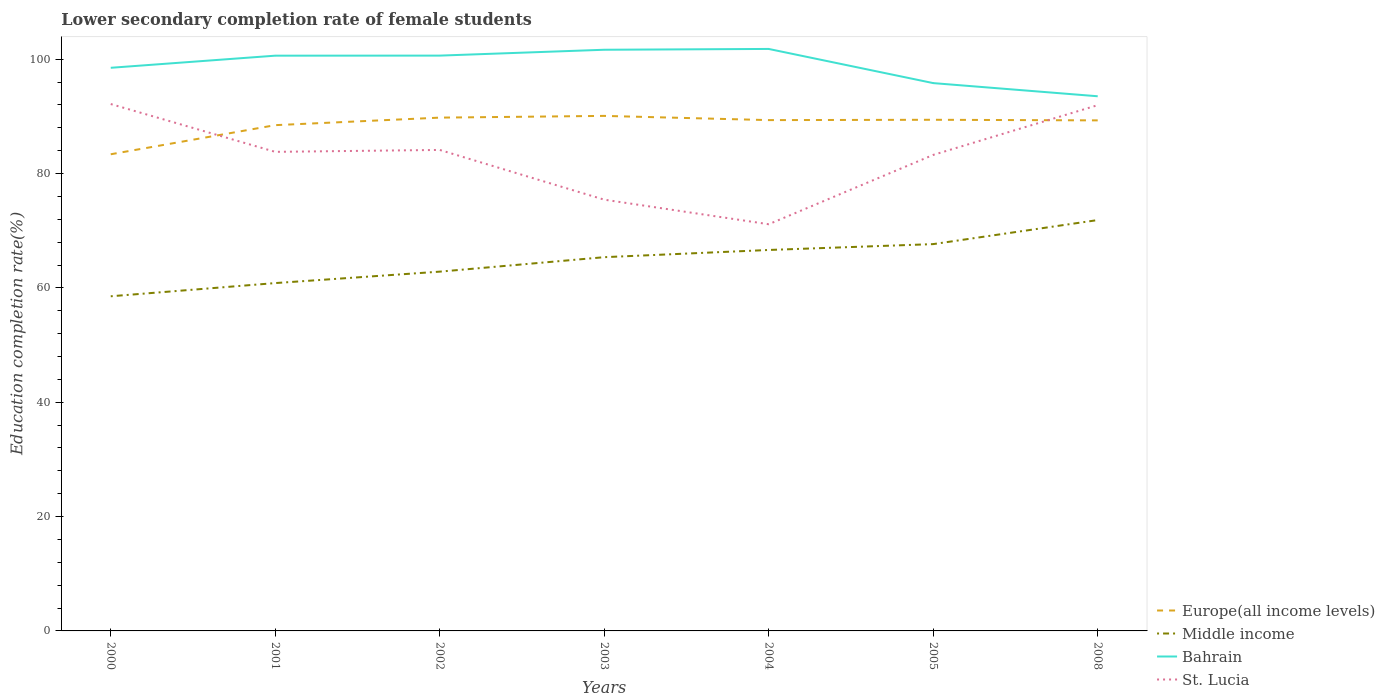How many different coloured lines are there?
Your answer should be very brief. 4. Is the number of lines equal to the number of legend labels?
Ensure brevity in your answer.  Yes. Across all years, what is the maximum lower secondary completion rate of female students in Bahrain?
Your response must be concise. 93.52. What is the total lower secondary completion rate of female students in St. Lucia in the graph?
Provide a short and direct response. -8.7. What is the difference between the highest and the second highest lower secondary completion rate of female students in Middle income?
Keep it short and to the point. 13.33. How many years are there in the graph?
Your answer should be compact. 7. Are the values on the major ticks of Y-axis written in scientific E-notation?
Offer a terse response. No. Does the graph contain any zero values?
Ensure brevity in your answer.  No. Where does the legend appear in the graph?
Provide a succinct answer. Bottom right. How many legend labels are there?
Keep it short and to the point. 4. How are the legend labels stacked?
Provide a succinct answer. Vertical. What is the title of the graph?
Offer a terse response. Lower secondary completion rate of female students. Does "Iran" appear as one of the legend labels in the graph?
Give a very brief answer. No. What is the label or title of the X-axis?
Keep it short and to the point. Years. What is the label or title of the Y-axis?
Make the answer very short. Education completion rate(%). What is the Education completion rate(%) in Europe(all income levels) in 2000?
Provide a short and direct response. 83.38. What is the Education completion rate(%) in Middle income in 2000?
Your answer should be compact. 58.54. What is the Education completion rate(%) in Bahrain in 2000?
Offer a very short reply. 98.5. What is the Education completion rate(%) in St. Lucia in 2000?
Your answer should be very brief. 92.16. What is the Education completion rate(%) in Europe(all income levels) in 2001?
Make the answer very short. 88.47. What is the Education completion rate(%) in Middle income in 2001?
Provide a short and direct response. 60.85. What is the Education completion rate(%) of Bahrain in 2001?
Your answer should be very brief. 100.62. What is the Education completion rate(%) of St. Lucia in 2001?
Your answer should be very brief. 83.8. What is the Education completion rate(%) of Europe(all income levels) in 2002?
Your response must be concise. 89.79. What is the Education completion rate(%) of Middle income in 2002?
Offer a terse response. 62.85. What is the Education completion rate(%) in Bahrain in 2002?
Your answer should be very brief. 100.64. What is the Education completion rate(%) in St. Lucia in 2002?
Your response must be concise. 84.14. What is the Education completion rate(%) in Europe(all income levels) in 2003?
Provide a short and direct response. 90.09. What is the Education completion rate(%) in Middle income in 2003?
Provide a succinct answer. 65.38. What is the Education completion rate(%) of Bahrain in 2003?
Provide a succinct answer. 101.66. What is the Education completion rate(%) of St. Lucia in 2003?
Your response must be concise. 75.44. What is the Education completion rate(%) of Europe(all income levels) in 2004?
Offer a very short reply. 89.35. What is the Education completion rate(%) in Middle income in 2004?
Provide a succinct answer. 66.64. What is the Education completion rate(%) of Bahrain in 2004?
Offer a terse response. 101.8. What is the Education completion rate(%) in St. Lucia in 2004?
Your answer should be very brief. 71.14. What is the Education completion rate(%) of Europe(all income levels) in 2005?
Make the answer very short. 89.41. What is the Education completion rate(%) in Middle income in 2005?
Your answer should be very brief. 67.66. What is the Education completion rate(%) in Bahrain in 2005?
Give a very brief answer. 95.83. What is the Education completion rate(%) of St. Lucia in 2005?
Ensure brevity in your answer.  83.27. What is the Education completion rate(%) in Europe(all income levels) in 2008?
Keep it short and to the point. 89.31. What is the Education completion rate(%) of Middle income in 2008?
Make the answer very short. 71.87. What is the Education completion rate(%) of Bahrain in 2008?
Your response must be concise. 93.52. What is the Education completion rate(%) of St. Lucia in 2008?
Provide a succinct answer. 91.97. Across all years, what is the maximum Education completion rate(%) in Europe(all income levels)?
Offer a very short reply. 90.09. Across all years, what is the maximum Education completion rate(%) in Middle income?
Offer a terse response. 71.87. Across all years, what is the maximum Education completion rate(%) of Bahrain?
Provide a short and direct response. 101.8. Across all years, what is the maximum Education completion rate(%) of St. Lucia?
Keep it short and to the point. 92.16. Across all years, what is the minimum Education completion rate(%) in Europe(all income levels)?
Ensure brevity in your answer.  83.38. Across all years, what is the minimum Education completion rate(%) of Middle income?
Offer a terse response. 58.54. Across all years, what is the minimum Education completion rate(%) of Bahrain?
Your answer should be very brief. 93.52. Across all years, what is the minimum Education completion rate(%) in St. Lucia?
Ensure brevity in your answer.  71.14. What is the total Education completion rate(%) of Europe(all income levels) in the graph?
Keep it short and to the point. 619.8. What is the total Education completion rate(%) of Middle income in the graph?
Your answer should be compact. 453.77. What is the total Education completion rate(%) in Bahrain in the graph?
Keep it short and to the point. 692.58. What is the total Education completion rate(%) of St. Lucia in the graph?
Give a very brief answer. 581.91. What is the difference between the Education completion rate(%) of Europe(all income levels) in 2000 and that in 2001?
Offer a terse response. -5.09. What is the difference between the Education completion rate(%) of Middle income in 2000 and that in 2001?
Your answer should be very brief. -2.31. What is the difference between the Education completion rate(%) of Bahrain in 2000 and that in 2001?
Offer a terse response. -2.12. What is the difference between the Education completion rate(%) in St. Lucia in 2000 and that in 2001?
Your answer should be very brief. 8.36. What is the difference between the Education completion rate(%) of Europe(all income levels) in 2000 and that in 2002?
Your answer should be compact. -6.41. What is the difference between the Education completion rate(%) in Middle income in 2000 and that in 2002?
Your answer should be very brief. -4.31. What is the difference between the Education completion rate(%) of Bahrain in 2000 and that in 2002?
Your answer should be compact. -2.13. What is the difference between the Education completion rate(%) of St. Lucia in 2000 and that in 2002?
Offer a very short reply. 8.03. What is the difference between the Education completion rate(%) of Europe(all income levels) in 2000 and that in 2003?
Your answer should be very brief. -6.71. What is the difference between the Education completion rate(%) in Middle income in 2000 and that in 2003?
Your answer should be very brief. -6.84. What is the difference between the Education completion rate(%) in Bahrain in 2000 and that in 2003?
Provide a short and direct response. -3.15. What is the difference between the Education completion rate(%) in St. Lucia in 2000 and that in 2003?
Ensure brevity in your answer.  16.73. What is the difference between the Education completion rate(%) of Europe(all income levels) in 2000 and that in 2004?
Provide a short and direct response. -5.98. What is the difference between the Education completion rate(%) in Middle income in 2000 and that in 2004?
Ensure brevity in your answer.  -8.1. What is the difference between the Education completion rate(%) in Bahrain in 2000 and that in 2004?
Provide a succinct answer. -3.3. What is the difference between the Education completion rate(%) of St. Lucia in 2000 and that in 2004?
Your answer should be very brief. 21.03. What is the difference between the Education completion rate(%) of Europe(all income levels) in 2000 and that in 2005?
Offer a terse response. -6.03. What is the difference between the Education completion rate(%) of Middle income in 2000 and that in 2005?
Offer a terse response. -9.12. What is the difference between the Education completion rate(%) of Bahrain in 2000 and that in 2005?
Provide a short and direct response. 2.68. What is the difference between the Education completion rate(%) of St. Lucia in 2000 and that in 2005?
Keep it short and to the point. 8.9. What is the difference between the Education completion rate(%) of Europe(all income levels) in 2000 and that in 2008?
Your answer should be compact. -5.93. What is the difference between the Education completion rate(%) of Middle income in 2000 and that in 2008?
Your answer should be very brief. -13.33. What is the difference between the Education completion rate(%) in Bahrain in 2000 and that in 2008?
Offer a very short reply. 4.98. What is the difference between the Education completion rate(%) of St. Lucia in 2000 and that in 2008?
Provide a short and direct response. 0.2. What is the difference between the Education completion rate(%) in Europe(all income levels) in 2001 and that in 2002?
Keep it short and to the point. -1.32. What is the difference between the Education completion rate(%) in Middle income in 2001 and that in 2002?
Offer a terse response. -2. What is the difference between the Education completion rate(%) of Bahrain in 2001 and that in 2002?
Your response must be concise. -0.01. What is the difference between the Education completion rate(%) in St. Lucia in 2001 and that in 2002?
Your answer should be very brief. -0.34. What is the difference between the Education completion rate(%) of Europe(all income levels) in 2001 and that in 2003?
Your answer should be compact. -1.62. What is the difference between the Education completion rate(%) in Middle income in 2001 and that in 2003?
Offer a terse response. -4.53. What is the difference between the Education completion rate(%) of Bahrain in 2001 and that in 2003?
Provide a short and direct response. -1.03. What is the difference between the Education completion rate(%) of St. Lucia in 2001 and that in 2003?
Provide a succinct answer. 8.36. What is the difference between the Education completion rate(%) in Europe(all income levels) in 2001 and that in 2004?
Give a very brief answer. -0.88. What is the difference between the Education completion rate(%) in Middle income in 2001 and that in 2004?
Your response must be concise. -5.79. What is the difference between the Education completion rate(%) of Bahrain in 2001 and that in 2004?
Keep it short and to the point. -1.18. What is the difference between the Education completion rate(%) in St. Lucia in 2001 and that in 2004?
Your answer should be very brief. 12.66. What is the difference between the Education completion rate(%) of Europe(all income levels) in 2001 and that in 2005?
Provide a short and direct response. -0.94. What is the difference between the Education completion rate(%) in Middle income in 2001 and that in 2005?
Provide a succinct answer. -6.82. What is the difference between the Education completion rate(%) of Bahrain in 2001 and that in 2005?
Your answer should be very brief. 4.8. What is the difference between the Education completion rate(%) in St. Lucia in 2001 and that in 2005?
Keep it short and to the point. 0.53. What is the difference between the Education completion rate(%) of Europe(all income levels) in 2001 and that in 2008?
Give a very brief answer. -0.83. What is the difference between the Education completion rate(%) of Middle income in 2001 and that in 2008?
Your answer should be compact. -11.02. What is the difference between the Education completion rate(%) of Bahrain in 2001 and that in 2008?
Provide a succinct answer. 7.1. What is the difference between the Education completion rate(%) in St. Lucia in 2001 and that in 2008?
Offer a terse response. -8.17. What is the difference between the Education completion rate(%) of Europe(all income levels) in 2002 and that in 2003?
Give a very brief answer. -0.3. What is the difference between the Education completion rate(%) in Middle income in 2002 and that in 2003?
Provide a short and direct response. -2.53. What is the difference between the Education completion rate(%) in Bahrain in 2002 and that in 2003?
Provide a succinct answer. -1.02. What is the difference between the Education completion rate(%) of St. Lucia in 2002 and that in 2003?
Provide a succinct answer. 8.7. What is the difference between the Education completion rate(%) of Europe(all income levels) in 2002 and that in 2004?
Provide a short and direct response. 0.43. What is the difference between the Education completion rate(%) in Middle income in 2002 and that in 2004?
Ensure brevity in your answer.  -3.79. What is the difference between the Education completion rate(%) of Bahrain in 2002 and that in 2004?
Your answer should be very brief. -1.17. What is the difference between the Education completion rate(%) of St. Lucia in 2002 and that in 2004?
Make the answer very short. 13. What is the difference between the Education completion rate(%) of Europe(all income levels) in 2002 and that in 2005?
Provide a short and direct response. 0.38. What is the difference between the Education completion rate(%) in Middle income in 2002 and that in 2005?
Make the answer very short. -4.82. What is the difference between the Education completion rate(%) of Bahrain in 2002 and that in 2005?
Offer a very short reply. 4.81. What is the difference between the Education completion rate(%) in St. Lucia in 2002 and that in 2005?
Keep it short and to the point. 0.87. What is the difference between the Education completion rate(%) of Europe(all income levels) in 2002 and that in 2008?
Offer a terse response. 0.48. What is the difference between the Education completion rate(%) in Middle income in 2002 and that in 2008?
Provide a succinct answer. -9.02. What is the difference between the Education completion rate(%) in Bahrain in 2002 and that in 2008?
Offer a very short reply. 7.11. What is the difference between the Education completion rate(%) of St. Lucia in 2002 and that in 2008?
Ensure brevity in your answer.  -7.83. What is the difference between the Education completion rate(%) of Europe(all income levels) in 2003 and that in 2004?
Give a very brief answer. 0.74. What is the difference between the Education completion rate(%) in Middle income in 2003 and that in 2004?
Provide a short and direct response. -1.26. What is the difference between the Education completion rate(%) of Bahrain in 2003 and that in 2004?
Give a very brief answer. -0.14. What is the difference between the Education completion rate(%) of St. Lucia in 2003 and that in 2004?
Provide a succinct answer. 4.3. What is the difference between the Education completion rate(%) of Europe(all income levels) in 2003 and that in 2005?
Your response must be concise. 0.68. What is the difference between the Education completion rate(%) in Middle income in 2003 and that in 2005?
Your answer should be very brief. -2.29. What is the difference between the Education completion rate(%) of Bahrain in 2003 and that in 2005?
Your response must be concise. 5.83. What is the difference between the Education completion rate(%) of St. Lucia in 2003 and that in 2005?
Offer a terse response. -7.83. What is the difference between the Education completion rate(%) of Europe(all income levels) in 2003 and that in 2008?
Keep it short and to the point. 0.78. What is the difference between the Education completion rate(%) of Middle income in 2003 and that in 2008?
Provide a succinct answer. -6.49. What is the difference between the Education completion rate(%) in Bahrain in 2003 and that in 2008?
Offer a very short reply. 8.14. What is the difference between the Education completion rate(%) of St. Lucia in 2003 and that in 2008?
Provide a short and direct response. -16.53. What is the difference between the Education completion rate(%) in Europe(all income levels) in 2004 and that in 2005?
Make the answer very short. -0.06. What is the difference between the Education completion rate(%) of Middle income in 2004 and that in 2005?
Give a very brief answer. -1.03. What is the difference between the Education completion rate(%) of Bahrain in 2004 and that in 2005?
Keep it short and to the point. 5.98. What is the difference between the Education completion rate(%) of St. Lucia in 2004 and that in 2005?
Offer a terse response. -12.13. What is the difference between the Education completion rate(%) of Europe(all income levels) in 2004 and that in 2008?
Ensure brevity in your answer.  0.05. What is the difference between the Education completion rate(%) of Middle income in 2004 and that in 2008?
Offer a very short reply. -5.23. What is the difference between the Education completion rate(%) of Bahrain in 2004 and that in 2008?
Provide a short and direct response. 8.28. What is the difference between the Education completion rate(%) of St. Lucia in 2004 and that in 2008?
Make the answer very short. -20.83. What is the difference between the Education completion rate(%) of Europe(all income levels) in 2005 and that in 2008?
Your answer should be very brief. 0.11. What is the difference between the Education completion rate(%) in Middle income in 2005 and that in 2008?
Provide a succinct answer. -4.21. What is the difference between the Education completion rate(%) of Bahrain in 2005 and that in 2008?
Offer a very short reply. 2.3. What is the difference between the Education completion rate(%) in St. Lucia in 2005 and that in 2008?
Keep it short and to the point. -8.7. What is the difference between the Education completion rate(%) of Europe(all income levels) in 2000 and the Education completion rate(%) of Middle income in 2001?
Offer a terse response. 22.53. What is the difference between the Education completion rate(%) in Europe(all income levels) in 2000 and the Education completion rate(%) in Bahrain in 2001?
Offer a very short reply. -17.25. What is the difference between the Education completion rate(%) in Europe(all income levels) in 2000 and the Education completion rate(%) in St. Lucia in 2001?
Keep it short and to the point. -0.42. What is the difference between the Education completion rate(%) in Middle income in 2000 and the Education completion rate(%) in Bahrain in 2001?
Make the answer very short. -42.09. What is the difference between the Education completion rate(%) of Middle income in 2000 and the Education completion rate(%) of St. Lucia in 2001?
Make the answer very short. -25.26. What is the difference between the Education completion rate(%) of Bahrain in 2000 and the Education completion rate(%) of St. Lucia in 2001?
Ensure brevity in your answer.  14.7. What is the difference between the Education completion rate(%) of Europe(all income levels) in 2000 and the Education completion rate(%) of Middle income in 2002?
Offer a terse response. 20.53. What is the difference between the Education completion rate(%) in Europe(all income levels) in 2000 and the Education completion rate(%) in Bahrain in 2002?
Offer a terse response. -17.26. What is the difference between the Education completion rate(%) in Europe(all income levels) in 2000 and the Education completion rate(%) in St. Lucia in 2002?
Offer a terse response. -0.76. What is the difference between the Education completion rate(%) of Middle income in 2000 and the Education completion rate(%) of Bahrain in 2002?
Keep it short and to the point. -42.1. What is the difference between the Education completion rate(%) of Middle income in 2000 and the Education completion rate(%) of St. Lucia in 2002?
Provide a succinct answer. -25.6. What is the difference between the Education completion rate(%) in Bahrain in 2000 and the Education completion rate(%) in St. Lucia in 2002?
Your answer should be very brief. 14.37. What is the difference between the Education completion rate(%) in Europe(all income levels) in 2000 and the Education completion rate(%) in Middle income in 2003?
Provide a succinct answer. 18. What is the difference between the Education completion rate(%) in Europe(all income levels) in 2000 and the Education completion rate(%) in Bahrain in 2003?
Your answer should be very brief. -18.28. What is the difference between the Education completion rate(%) of Europe(all income levels) in 2000 and the Education completion rate(%) of St. Lucia in 2003?
Provide a short and direct response. 7.94. What is the difference between the Education completion rate(%) of Middle income in 2000 and the Education completion rate(%) of Bahrain in 2003?
Ensure brevity in your answer.  -43.12. What is the difference between the Education completion rate(%) of Middle income in 2000 and the Education completion rate(%) of St. Lucia in 2003?
Your answer should be compact. -16.9. What is the difference between the Education completion rate(%) in Bahrain in 2000 and the Education completion rate(%) in St. Lucia in 2003?
Make the answer very short. 23.07. What is the difference between the Education completion rate(%) of Europe(all income levels) in 2000 and the Education completion rate(%) of Middle income in 2004?
Provide a short and direct response. 16.74. What is the difference between the Education completion rate(%) of Europe(all income levels) in 2000 and the Education completion rate(%) of Bahrain in 2004?
Keep it short and to the point. -18.42. What is the difference between the Education completion rate(%) in Europe(all income levels) in 2000 and the Education completion rate(%) in St. Lucia in 2004?
Make the answer very short. 12.24. What is the difference between the Education completion rate(%) of Middle income in 2000 and the Education completion rate(%) of Bahrain in 2004?
Offer a very short reply. -43.26. What is the difference between the Education completion rate(%) in Middle income in 2000 and the Education completion rate(%) in St. Lucia in 2004?
Make the answer very short. -12.6. What is the difference between the Education completion rate(%) of Bahrain in 2000 and the Education completion rate(%) of St. Lucia in 2004?
Give a very brief answer. 27.37. What is the difference between the Education completion rate(%) of Europe(all income levels) in 2000 and the Education completion rate(%) of Middle income in 2005?
Give a very brief answer. 15.71. What is the difference between the Education completion rate(%) in Europe(all income levels) in 2000 and the Education completion rate(%) in Bahrain in 2005?
Your answer should be very brief. -12.45. What is the difference between the Education completion rate(%) in Europe(all income levels) in 2000 and the Education completion rate(%) in St. Lucia in 2005?
Provide a succinct answer. 0.11. What is the difference between the Education completion rate(%) of Middle income in 2000 and the Education completion rate(%) of Bahrain in 2005?
Ensure brevity in your answer.  -37.29. What is the difference between the Education completion rate(%) in Middle income in 2000 and the Education completion rate(%) in St. Lucia in 2005?
Make the answer very short. -24.73. What is the difference between the Education completion rate(%) in Bahrain in 2000 and the Education completion rate(%) in St. Lucia in 2005?
Keep it short and to the point. 15.24. What is the difference between the Education completion rate(%) of Europe(all income levels) in 2000 and the Education completion rate(%) of Middle income in 2008?
Give a very brief answer. 11.51. What is the difference between the Education completion rate(%) in Europe(all income levels) in 2000 and the Education completion rate(%) in Bahrain in 2008?
Your answer should be compact. -10.15. What is the difference between the Education completion rate(%) in Europe(all income levels) in 2000 and the Education completion rate(%) in St. Lucia in 2008?
Provide a succinct answer. -8.59. What is the difference between the Education completion rate(%) in Middle income in 2000 and the Education completion rate(%) in Bahrain in 2008?
Give a very brief answer. -34.99. What is the difference between the Education completion rate(%) of Middle income in 2000 and the Education completion rate(%) of St. Lucia in 2008?
Ensure brevity in your answer.  -33.43. What is the difference between the Education completion rate(%) in Bahrain in 2000 and the Education completion rate(%) in St. Lucia in 2008?
Keep it short and to the point. 6.54. What is the difference between the Education completion rate(%) in Europe(all income levels) in 2001 and the Education completion rate(%) in Middle income in 2002?
Offer a very short reply. 25.62. What is the difference between the Education completion rate(%) in Europe(all income levels) in 2001 and the Education completion rate(%) in Bahrain in 2002?
Your answer should be very brief. -12.16. What is the difference between the Education completion rate(%) of Europe(all income levels) in 2001 and the Education completion rate(%) of St. Lucia in 2002?
Give a very brief answer. 4.33. What is the difference between the Education completion rate(%) of Middle income in 2001 and the Education completion rate(%) of Bahrain in 2002?
Give a very brief answer. -39.79. What is the difference between the Education completion rate(%) of Middle income in 2001 and the Education completion rate(%) of St. Lucia in 2002?
Your response must be concise. -23.29. What is the difference between the Education completion rate(%) of Bahrain in 2001 and the Education completion rate(%) of St. Lucia in 2002?
Offer a very short reply. 16.49. What is the difference between the Education completion rate(%) of Europe(all income levels) in 2001 and the Education completion rate(%) of Middle income in 2003?
Give a very brief answer. 23.09. What is the difference between the Education completion rate(%) of Europe(all income levels) in 2001 and the Education completion rate(%) of Bahrain in 2003?
Ensure brevity in your answer.  -13.19. What is the difference between the Education completion rate(%) in Europe(all income levels) in 2001 and the Education completion rate(%) in St. Lucia in 2003?
Provide a succinct answer. 13.03. What is the difference between the Education completion rate(%) of Middle income in 2001 and the Education completion rate(%) of Bahrain in 2003?
Offer a terse response. -40.81. What is the difference between the Education completion rate(%) of Middle income in 2001 and the Education completion rate(%) of St. Lucia in 2003?
Give a very brief answer. -14.59. What is the difference between the Education completion rate(%) of Bahrain in 2001 and the Education completion rate(%) of St. Lucia in 2003?
Offer a terse response. 25.19. What is the difference between the Education completion rate(%) of Europe(all income levels) in 2001 and the Education completion rate(%) of Middle income in 2004?
Keep it short and to the point. 21.83. What is the difference between the Education completion rate(%) in Europe(all income levels) in 2001 and the Education completion rate(%) in Bahrain in 2004?
Ensure brevity in your answer.  -13.33. What is the difference between the Education completion rate(%) in Europe(all income levels) in 2001 and the Education completion rate(%) in St. Lucia in 2004?
Give a very brief answer. 17.33. What is the difference between the Education completion rate(%) in Middle income in 2001 and the Education completion rate(%) in Bahrain in 2004?
Keep it short and to the point. -40.96. What is the difference between the Education completion rate(%) of Middle income in 2001 and the Education completion rate(%) of St. Lucia in 2004?
Provide a short and direct response. -10.29. What is the difference between the Education completion rate(%) in Bahrain in 2001 and the Education completion rate(%) in St. Lucia in 2004?
Your answer should be compact. 29.49. What is the difference between the Education completion rate(%) of Europe(all income levels) in 2001 and the Education completion rate(%) of Middle income in 2005?
Your answer should be compact. 20.81. What is the difference between the Education completion rate(%) of Europe(all income levels) in 2001 and the Education completion rate(%) of Bahrain in 2005?
Keep it short and to the point. -7.36. What is the difference between the Education completion rate(%) in Europe(all income levels) in 2001 and the Education completion rate(%) in St. Lucia in 2005?
Give a very brief answer. 5.2. What is the difference between the Education completion rate(%) of Middle income in 2001 and the Education completion rate(%) of Bahrain in 2005?
Give a very brief answer. -34.98. What is the difference between the Education completion rate(%) in Middle income in 2001 and the Education completion rate(%) in St. Lucia in 2005?
Provide a short and direct response. -22.42. What is the difference between the Education completion rate(%) of Bahrain in 2001 and the Education completion rate(%) of St. Lucia in 2005?
Your answer should be compact. 17.36. What is the difference between the Education completion rate(%) of Europe(all income levels) in 2001 and the Education completion rate(%) of Middle income in 2008?
Ensure brevity in your answer.  16.6. What is the difference between the Education completion rate(%) in Europe(all income levels) in 2001 and the Education completion rate(%) in Bahrain in 2008?
Your answer should be compact. -5.05. What is the difference between the Education completion rate(%) in Europe(all income levels) in 2001 and the Education completion rate(%) in St. Lucia in 2008?
Your answer should be very brief. -3.5. What is the difference between the Education completion rate(%) in Middle income in 2001 and the Education completion rate(%) in Bahrain in 2008?
Give a very brief answer. -32.68. What is the difference between the Education completion rate(%) in Middle income in 2001 and the Education completion rate(%) in St. Lucia in 2008?
Offer a terse response. -31.12. What is the difference between the Education completion rate(%) in Bahrain in 2001 and the Education completion rate(%) in St. Lucia in 2008?
Provide a succinct answer. 8.66. What is the difference between the Education completion rate(%) in Europe(all income levels) in 2002 and the Education completion rate(%) in Middle income in 2003?
Provide a short and direct response. 24.41. What is the difference between the Education completion rate(%) in Europe(all income levels) in 2002 and the Education completion rate(%) in Bahrain in 2003?
Give a very brief answer. -11.87. What is the difference between the Education completion rate(%) of Europe(all income levels) in 2002 and the Education completion rate(%) of St. Lucia in 2003?
Ensure brevity in your answer.  14.35. What is the difference between the Education completion rate(%) of Middle income in 2002 and the Education completion rate(%) of Bahrain in 2003?
Make the answer very short. -38.81. What is the difference between the Education completion rate(%) of Middle income in 2002 and the Education completion rate(%) of St. Lucia in 2003?
Make the answer very short. -12.59. What is the difference between the Education completion rate(%) of Bahrain in 2002 and the Education completion rate(%) of St. Lucia in 2003?
Ensure brevity in your answer.  25.2. What is the difference between the Education completion rate(%) of Europe(all income levels) in 2002 and the Education completion rate(%) of Middle income in 2004?
Provide a short and direct response. 23.15. What is the difference between the Education completion rate(%) of Europe(all income levels) in 2002 and the Education completion rate(%) of Bahrain in 2004?
Give a very brief answer. -12.02. What is the difference between the Education completion rate(%) of Europe(all income levels) in 2002 and the Education completion rate(%) of St. Lucia in 2004?
Offer a terse response. 18.65. What is the difference between the Education completion rate(%) of Middle income in 2002 and the Education completion rate(%) of Bahrain in 2004?
Offer a terse response. -38.96. What is the difference between the Education completion rate(%) in Middle income in 2002 and the Education completion rate(%) in St. Lucia in 2004?
Offer a terse response. -8.29. What is the difference between the Education completion rate(%) in Bahrain in 2002 and the Education completion rate(%) in St. Lucia in 2004?
Keep it short and to the point. 29.5. What is the difference between the Education completion rate(%) of Europe(all income levels) in 2002 and the Education completion rate(%) of Middle income in 2005?
Ensure brevity in your answer.  22.12. What is the difference between the Education completion rate(%) of Europe(all income levels) in 2002 and the Education completion rate(%) of Bahrain in 2005?
Your answer should be compact. -6.04. What is the difference between the Education completion rate(%) in Europe(all income levels) in 2002 and the Education completion rate(%) in St. Lucia in 2005?
Offer a terse response. 6.52. What is the difference between the Education completion rate(%) of Middle income in 2002 and the Education completion rate(%) of Bahrain in 2005?
Provide a succinct answer. -32.98. What is the difference between the Education completion rate(%) in Middle income in 2002 and the Education completion rate(%) in St. Lucia in 2005?
Ensure brevity in your answer.  -20.42. What is the difference between the Education completion rate(%) in Bahrain in 2002 and the Education completion rate(%) in St. Lucia in 2005?
Keep it short and to the point. 17.37. What is the difference between the Education completion rate(%) in Europe(all income levels) in 2002 and the Education completion rate(%) in Middle income in 2008?
Your answer should be very brief. 17.92. What is the difference between the Education completion rate(%) in Europe(all income levels) in 2002 and the Education completion rate(%) in Bahrain in 2008?
Your answer should be very brief. -3.74. What is the difference between the Education completion rate(%) of Europe(all income levels) in 2002 and the Education completion rate(%) of St. Lucia in 2008?
Your response must be concise. -2.18. What is the difference between the Education completion rate(%) of Middle income in 2002 and the Education completion rate(%) of Bahrain in 2008?
Offer a very short reply. -30.68. What is the difference between the Education completion rate(%) of Middle income in 2002 and the Education completion rate(%) of St. Lucia in 2008?
Keep it short and to the point. -29.12. What is the difference between the Education completion rate(%) in Bahrain in 2002 and the Education completion rate(%) in St. Lucia in 2008?
Provide a short and direct response. 8.67. What is the difference between the Education completion rate(%) in Europe(all income levels) in 2003 and the Education completion rate(%) in Middle income in 2004?
Keep it short and to the point. 23.45. What is the difference between the Education completion rate(%) in Europe(all income levels) in 2003 and the Education completion rate(%) in Bahrain in 2004?
Give a very brief answer. -11.71. What is the difference between the Education completion rate(%) in Europe(all income levels) in 2003 and the Education completion rate(%) in St. Lucia in 2004?
Your answer should be very brief. 18.95. What is the difference between the Education completion rate(%) of Middle income in 2003 and the Education completion rate(%) of Bahrain in 2004?
Offer a very short reply. -36.43. What is the difference between the Education completion rate(%) of Middle income in 2003 and the Education completion rate(%) of St. Lucia in 2004?
Offer a terse response. -5.76. What is the difference between the Education completion rate(%) of Bahrain in 2003 and the Education completion rate(%) of St. Lucia in 2004?
Ensure brevity in your answer.  30.52. What is the difference between the Education completion rate(%) in Europe(all income levels) in 2003 and the Education completion rate(%) in Middle income in 2005?
Offer a very short reply. 22.43. What is the difference between the Education completion rate(%) in Europe(all income levels) in 2003 and the Education completion rate(%) in Bahrain in 2005?
Offer a terse response. -5.74. What is the difference between the Education completion rate(%) of Europe(all income levels) in 2003 and the Education completion rate(%) of St. Lucia in 2005?
Your answer should be very brief. 6.82. What is the difference between the Education completion rate(%) in Middle income in 2003 and the Education completion rate(%) in Bahrain in 2005?
Provide a succinct answer. -30.45. What is the difference between the Education completion rate(%) of Middle income in 2003 and the Education completion rate(%) of St. Lucia in 2005?
Make the answer very short. -17.89. What is the difference between the Education completion rate(%) of Bahrain in 2003 and the Education completion rate(%) of St. Lucia in 2005?
Offer a terse response. 18.39. What is the difference between the Education completion rate(%) of Europe(all income levels) in 2003 and the Education completion rate(%) of Middle income in 2008?
Provide a succinct answer. 18.22. What is the difference between the Education completion rate(%) in Europe(all income levels) in 2003 and the Education completion rate(%) in Bahrain in 2008?
Offer a very short reply. -3.43. What is the difference between the Education completion rate(%) in Europe(all income levels) in 2003 and the Education completion rate(%) in St. Lucia in 2008?
Make the answer very short. -1.88. What is the difference between the Education completion rate(%) in Middle income in 2003 and the Education completion rate(%) in Bahrain in 2008?
Offer a terse response. -28.15. What is the difference between the Education completion rate(%) in Middle income in 2003 and the Education completion rate(%) in St. Lucia in 2008?
Your answer should be very brief. -26.59. What is the difference between the Education completion rate(%) in Bahrain in 2003 and the Education completion rate(%) in St. Lucia in 2008?
Provide a succinct answer. 9.69. What is the difference between the Education completion rate(%) of Europe(all income levels) in 2004 and the Education completion rate(%) of Middle income in 2005?
Provide a succinct answer. 21.69. What is the difference between the Education completion rate(%) of Europe(all income levels) in 2004 and the Education completion rate(%) of Bahrain in 2005?
Offer a terse response. -6.47. What is the difference between the Education completion rate(%) of Europe(all income levels) in 2004 and the Education completion rate(%) of St. Lucia in 2005?
Offer a very short reply. 6.09. What is the difference between the Education completion rate(%) in Middle income in 2004 and the Education completion rate(%) in Bahrain in 2005?
Ensure brevity in your answer.  -29.19. What is the difference between the Education completion rate(%) of Middle income in 2004 and the Education completion rate(%) of St. Lucia in 2005?
Provide a short and direct response. -16.63. What is the difference between the Education completion rate(%) of Bahrain in 2004 and the Education completion rate(%) of St. Lucia in 2005?
Offer a very short reply. 18.53. What is the difference between the Education completion rate(%) in Europe(all income levels) in 2004 and the Education completion rate(%) in Middle income in 2008?
Provide a short and direct response. 17.48. What is the difference between the Education completion rate(%) of Europe(all income levels) in 2004 and the Education completion rate(%) of Bahrain in 2008?
Offer a very short reply. -4.17. What is the difference between the Education completion rate(%) in Europe(all income levels) in 2004 and the Education completion rate(%) in St. Lucia in 2008?
Your answer should be very brief. -2.61. What is the difference between the Education completion rate(%) of Middle income in 2004 and the Education completion rate(%) of Bahrain in 2008?
Your answer should be compact. -26.89. What is the difference between the Education completion rate(%) of Middle income in 2004 and the Education completion rate(%) of St. Lucia in 2008?
Your answer should be very brief. -25.33. What is the difference between the Education completion rate(%) in Bahrain in 2004 and the Education completion rate(%) in St. Lucia in 2008?
Give a very brief answer. 9.83. What is the difference between the Education completion rate(%) in Europe(all income levels) in 2005 and the Education completion rate(%) in Middle income in 2008?
Offer a very short reply. 17.54. What is the difference between the Education completion rate(%) of Europe(all income levels) in 2005 and the Education completion rate(%) of Bahrain in 2008?
Offer a terse response. -4.11. What is the difference between the Education completion rate(%) in Europe(all income levels) in 2005 and the Education completion rate(%) in St. Lucia in 2008?
Provide a short and direct response. -2.56. What is the difference between the Education completion rate(%) of Middle income in 2005 and the Education completion rate(%) of Bahrain in 2008?
Your answer should be compact. -25.86. What is the difference between the Education completion rate(%) of Middle income in 2005 and the Education completion rate(%) of St. Lucia in 2008?
Your response must be concise. -24.3. What is the difference between the Education completion rate(%) in Bahrain in 2005 and the Education completion rate(%) in St. Lucia in 2008?
Keep it short and to the point. 3.86. What is the average Education completion rate(%) of Europe(all income levels) per year?
Make the answer very short. 88.54. What is the average Education completion rate(%) of Middle income per year?
Make the answer very short. 64.82. What is the average Education completion rate(%) of Bahrain per year?
Provide a short and direct response. 98.94. What is the average Education completion rate(%) of St. Lucia per year?
Offer a terse response. 83.13. In the year 2000, what is the difference between the Education completion rate(%) in Europe(all income levels) and Education completion rate(%) in Middle income?
Provide a short and direct response. 24.84. In the year 2000, what is the difference between the Education completion rate(%) of Europe(all income levels) and Education completion rate(%) of Bahrain?
Your response must be concise. -15.13. In the year 2000, what is the difference between the Education completion rate(%) of Europe(all income levels) and Education completion rate(%) of St. Lucia?
Your answer should be compact. -8.79. In the year 2000, what is the difference between the Education completion rate(%) in Middle income and Education completion rate(%) in Bahrain?
Your response must be concise. -39.97. In the year 2000, what is the difference between the Education completion rate(%) of Middle income and Education completion rate(%) of St. Lucia?
Ensure brevity in your answer.  -33.63. In the year 2000, what is the difference between the Education completion rate(%) in Bahrain and Education completion rate(%) in St. Lucia?
Provide a succinct answer. 6.34. In the year 2001, what is the difference between the Education completion rate(%) in Europe(all income levels) and Education completion rate(%) in Middle income?
Keep it short and to the point. 27.63. In the year 2001, what is the difference between the Education completion rate(%) in Europe(all income levels) and Education completion rate(%) in Bahrain?
Your answer should be compact. -12.15. In the year 2001, what is the difference between the Education completion rate(%) in Europe(all income levels) and Education completion rate(%) in St. Lucia?
Offer a terse response. 4.67. In the year 2001, what is the difference between the Education completion rate(%) of Middle income and Education completion rate(%) of Bahrain?
Offer a very short reply. -39.78. In the year 2001, what is the difference between the Education completion rate(%) in Middle income and Education completion rate(%) in St. Lucia?
Offer a terse response. -22.96. In the year 2001, what is the difference between the Education completion rate(%) in Bahrain and Education completion rate(%) in St. Lucia?
Offer a very short reply. 16.82. In the year 2002, what is the difference between the Education completion rate(%) of Europe(all income levels) and Education completion rate(%) of Middle income?
Your answer should be very brief. 26.94. In the year 2002, what is the difference between the Education completion rate(%) in Europe(all income levels) and Education completion rate(%) in Bahrain?
Offer a very short reply. -10.85. In the year 2002, what is the difference between the Education completion rate(%) of Europe(all income levels) and Education completion rate(%) of St. Lucia?
Your answer should be very brief. 5.65. In the year 2002, what is the difference between the Education completion rate(%) in Middle income and Education completion rate(%) in Bahrain?
Provide a succinct answer. -37.79. In the year 2002, what is the difference between the Education completion rate(%) in Middle income and Education completion rate(%) in St. Lucia?
Make the answer very short. -21.29. In the year 2002, what is the difference between the Education completion rate(%) in Bahrain and Education completion rate(%) in St. Lucia?
Provide a short and direct response. 16.5. In the year 2003, what is the difference between the Education completion rate(%) of Europe(all income levels) and Education completion rate(%) of Middle income?
Ensure brevity in your answer.  24.71. In the year 2003, what is the difference between the Education completion rate(%) in Europe(all income levels) and Education completion rate(%) in Bahrain?
Offer a terse response. -11.57. In the year 2003, what is the difference between the Education completion rate(%) in Europe(all income levels) and Education completion rate(%) in St. Lucia?
Offer a terse response. 14.65. In the year 2003, what is the difference between the Education completion rate(%) in Middle income and Education completion rate(%) in Bahrain?
Your response must be concise. -36.28. In the year 2003, what is the difference between the Education completion rate(%) in Middle income and Education completion rate(%) in St. Lucia?
Provide a short and direct response. -10.06. In the year 2003, what is the difference between the Education completion rate(%) of Bahrain and Education completion rate(%) of St. Lucia?
Offer a terse response. 26.22. In the year 2004, what is the difference between the Education completion rate(%) of Europe(all income levels) and Education completion rate(%) of Middle income?
Give a very brief answer. 22.72. In the year 2004, what is the difference between the Education completion rate(%) in Europe(all income levels) and Education completion rate(%) in Bahrain?
Your answer should be compact. -12.45. In the year 2004, what is the difference between the Education completion rate(%) of Europe(all income levels) and Education completion rate(%) of St. Lucia?
Keep it short and to the point. 18.21. In the year 2004, what is the difference between the Education completion rate(%) in Middle income and Education completion rate(%) in Bahrain?
Offer a very short reply. -35.16. In the year 2004, what is the difference between the Education completion rate(%) in Middle income and Education completion rate(%) in St. Lucia?
Give a very brief answer. -4.5. In the year 2004, what is the difference between the Education completion rate(%) of Bahrain and Education completion rate(%) of St. Lucia?
Keep it short and to the point. 30.66. In the year 2005, what is the difference between the Education completion rate(%) in Europe(all income levels) and Education completion rate(%) in Middle income?
Provide a short and direct response. 21.75. In the year 2005, what is the difference between the Education completion rate(%) in Europe(all income levels) and Education completion rate(%) in Bahrain?
Your answer should be very brief. -6.41. In the year 2005, what is the difference between the Education completion rate(%) of Europe(all income levels) and Education completion rate(%) of St. Lucia?
Offer a terse response. 6.14. In the year 2005, what is the difference between the Education completion rate(%) of Middle income and Education completion rate(%) of Bahrain?
Ensure brevity in your answer.  -28.16. In the year 2005, what is the difference between the Education completion rate(%) in Middle income and Education completion rate(%) in St. Lucia?
Offer a terse response. -15.6. In the year 2005, what is the difference between the Education completion rate(%) in Bahrain and Education completion rate(%) in St. Lucia?
Ensure brevity in your answer.  12.56. In the year 2008, what is the difference between the Education completion rate(%) of Europe(all income levels) and Education completion rate(%) of Middle income?
Offer a terse response. 17.44. In the year 2008, what is the difference between the Education completion rate(%) in Europe(all income levels) and Education completion rate(%) in Bahrain?
Keep it short and to the point. -4.22. In the year 2008, what is the difference between the Education completion rate(%) in Europe(all income levels) and Education completion rate(%) in St. Lucia?
Your response must be concise. -2.66. In the year 2008, what is the difference between the Education completion rate(%) of Middle income and Education completion rate(%) of Bahrain?
Give a very brief answer. -21.66. In the year 2008, what is the difference between the Education completion rate(%) in Middle income and Education completion rate(%) in St. Lucia?
Your response must be concise. -20.1. In the year 2008, what is the difference between the Education completion rate(%) of Bahrain and Education completion rate(%) of St. Lucia?
Give a very brief answer. 1.56. What is the ratio of the Education completion rate(%) of Europe(all income levels) in 2000 to that in 2001?
Keep it short and to the point. 0.94. What is the ratio of the Education completion rate(%) of Middle income in 2000 to that in 2001?
Your answer should be very brief. 0.96. What is the ratio of the Education completion rate(%) in Bahrain in 2000 to that in 2001?
Ensure brevity in your answer.  0.98. What is the ratio of the Education completion rate(%) of St. Lucia in 2000 to that in 2001?
Give a very brief answer. 1.1. What is the ratio of the Education completion rate(%) of Europe(all income levels) in 2000 to that in 2002?
Ensure brevity in your answer.  0.93. What is the ratio of the Education completion rate(%) in Middle income in 2000 to that in 2002?
Keep it short and to the point. 0.93. What is the ratio of the Education completion rate(%) in Bahrain in 2000 to that in 2002?
Give a very brief answer. 0.98. What is the ratio of the Education completion rate(%) in St. Lucia in 2000 to that in 2002?
Your response must be concise. 1.1. What is the ratio of the Education completion rate(%) of Europe(all income levels) in 2000 to that in 2003?
Make the answer very short. 0.93. What is the ratio of the Education completion rate(%) in Middle income in 2000 to that in 2003?
Provide a short and direct response. 0.9. What is the ratio of the Education completion rate(%) of St. Lucia in 2000 to that in 2003?
Keep it short and to the point. 1.22. What is the ratio of the Education completion rate(%) of Europe(all income levels) in 2000 to that in 2004?
Ensure brevity in your answer.  0.93. What is the ratio of the Education completion rate(%) of Middle income in 2000 to that in 2004?
Your response must be concise. 0.88. What is the ratio of the Education completion rate(%) in Bahrain in 2000 to that in 2004?
Provide a short and direct response. 0.97. What is the ratio of the Education completion rate(%) of St. Lucia in 2000 to that in 2004?
Make the answer very short. 1.3. What is the ratio of the Education completion rate(%) in Europe(all income levels) in 2000 to that in 2005?
Provide a succinct answer. 0.93. What is the ratio of the Education completion rate(%) in Middle income in 2000 to that in 2005?
Make the answer very short. 0.87. What is the ratio of the Education completion rate(%) in Bahrain in 2000 to that in 2005?
Provide a succinct answer. 1.03. What is the ratio of the Education completion rate(%) of St. Lucia in 2000 to that in 2005?
Keep it short and to the point. 1.11. What is the ratio of the Education completion rate(%) in Europe(all income levels) in 2000 to that in 2008?
Your answer should be very brief. 0.93. What is the ratio of the Education completion rate(%) of Middle income in 2000 to that in 2008?
Your answer should be very brief. 0.81. What is the ratio of the Education completion rate(%) in Bahrain in 2000 to that in 2008?
Provide a succinct answer. 1.05. What is the ratio of the Education completion rate(%) in St. Lucia in 2000 to that in 2008?
Ensure brevity in your answer.  1. What is the ratio of the Education completion rate(%) of Europe(all income levels) in 2001 to that in 2002?
Provide a short and direct response. 0.99. What is the ratio of the Education completion rate(%) of Middle income in 2001 to that in 2002?
Provide a succinct answer. 0.97. What is the ratio of the Education completion rate(%) in St. Lucia in 2001 to that in 2002?
Give a very brief answer. 1. What is the ratio of the Education completion rate(%) in Europe(all income levels) in 2001 to that in 2003?
Ensure brevity in your answer.  0.98. What is the ratio of the Education completion rate(%) in Middle income in 2001 to that in 2003?
Your response must be concise. 0.93. What is the ratio of the Education completion rate(%) of St. Lucia in 2001 to that in 2003?
Offer a very short reply. 1.11. What is the ratio of the Education completion rate(%) in Middle income in 2001 to that in 2004?
Make the answer very short. 0.91. What is the ratio of the Education completion rate(%) in Bahrain in 2001 to that in 2004?
Your answer should be very brief. 0.99. What is the ratio of the Education completion rate(%) of St. Lucia in 2001 to that in 2004?
Offer a very short reply. 1.18. What is the ratio of the Education completion rate(%) in Middle income in 2001 to that in 2005?
Offer a very short reply. 0.9. What is the ratio of the Education completion rate(%) in Bahrain in 2001 to that in 2005?
Provide a short and direct response. 1.05. What is the ratio of the Education completion rate(%) in St. Lucia in 2001 to that in 2005?
Your answer should be very brief. 1.01. What is the ratio of the Education completion rate(%) in Middle income in 2001 to that in 2008?
Make the answer very short. 0.85. What is the ratio of the Education completion rate(%) in Bahrain in 2001 to that in 2008?
Provide a succinct answer. 1.08. What is the ratio of the Education completion rate(%) of St. Lucia in 2001 to that in 2008?
Give a very brief answer. 0.91. What is the ratio of the Education completion rate(%) of Europe(all income levels) in 2002 to that in 2003?
Provide a short and direct response. 1. What is the ratio of the Education completion rate(%) of Middle income in 2002 to that in 2003?
Your response must be concise. 0.96. What is the ratio of the Education completion rate(%) in St. Lucia in 2002 to that in 2003?
Give a very brief answer. 1.12. What is the ratio of the Education completion rate(%) in Middle income in 2002 to that in 2004?
Provide a short and direct response. 0.94. What is the ratio of the Education completion rate(%) in St. Lucia in 2002 to that in 2004?
Your answer should be very brief. 1.18. What is the ratio of the Education completion rate(%) of Europe(all income levels) in 2002 to that in 2005?
Make the answer very short. 1. What is the ratio of the Education completion rate(%) of Middle income in 2002 to that in 2005?
Keep it short and to the point. 0.93. What is the ratio of the Education completion rate(%) in Bahrain in 2002 to that in 2005?
Your response must be concise. 1.05. What is the ratio of the Education completion rate(%) of St. Lucia in 2002 to that in 2005?
Your answer should be very brief. 1.01. What is the ratio of the Education completion rate(%) in Europe(all income levels) in 2002 to that in 2008?
Provide a short and direct response. 1.01. What is the ratio of the Education completion rate(%) of Middle income in 2002 to that in 2008?
Give a very brief answer. 0.87. What is the ratio of the Education completion rate(%) of Bahrain in 2002 to that in 2008?
Keep it short and to the point. 1.08. What is the ratio of the Education completion rate(%) in St. Lucia in 2002 to that in 2008?
Provide a short and direct response. 0.91. What is the ratio of the Education completion rate(%) in Europe(all income levels) in 2003 to that in 2004?
Offer a terse response. 1.01. What is the ratio of the Education completion rate(%) in Middle income in 2003 to that in 2004?
Your answer should be very brief. 0.98. What is the ratio of the Education completion rate(%) in Bahrain in 2003 to that in 2004?
Your response must be concise. 1. What is the ratio of the Education completion rate(%) of St. Lucia in 2003 to that in 2004?
Your answer should be compact. 1.06. What is the ratio of the Education completion rate(%) in Europe(all income levels) in 2003 to that in 2005?
Offer a very short reply. 1.01. What is the ratio of the Education completion rate(%) in Middle income in 2003 to that in 2005?
Make the answer very short. 0.97. What is the ratio of the Education completion rate(%) of Bahrain in 2003 to that in 2005?
Offer a terse response. 1.06. What is the ratio of the Education completion rate(%) of St. Lucia in 2003 to that in 2005?
Provide a short and direct response. 0.91. What is the ratio of the Education completion rate(%) of Europe(all income levels) in 2003 to that in 2008?
Offer a very short reply. 1.01. What is the ratio of the Education completion rate(%) of Middle income in 2003 to that in 2008?
Your answer should be very brief. 0.91. What is the ratio of the Education completion rate(%) of Bahrain in 2003 to that in 2008?
Provide a succinct answer. 1.09. What is the ratio of the Education completion rate(%) in St. Lucia in 2003 to that in 2008?
Provide a short and direct response. 0.82. What is the ratio of the Education completion rate(%) of Europe(all income levels) in 2004 to that in 2005?
Your answer should be compact. 1. What is the ratio of the Education completion rate(%) in Middle income in 2004 to that in 2005?
Ensure brevity in your answer.  0.98. What is the ratio of the Education completion rate(%) of Bahrain in 2004 to that in 2005?
Your answer should be very brief. 1.06. What is the ratio of the Education completion rate(%) of St. Lucia in 2004 to that in 2005?
Ensure brevity in your answer.  0.85. What is the ratio of the Education completion rate(%) in Middle income in 2004 to that in 2008?
Provide a succinct answer. 0.93. What is the ratio of the Education completion rate(%) of Bahrain in 2004 to that in 2008?
Your response must be concise. 1.09. What is the ratio of the Education completion rate(%) of St. Lucia in 2004 to that in 2008?
Offer a terse response. 0.77. What is the ratio of the Education completion rate(%) of Middle income in 2005 to that in 2008?
Offer a terse response. 0.94. What is the ratio of the Education completion rate(%) in Bahrain in 2005 to that in 2008?
Your answer should be very brief. 1.02. What is the ratio of the Education completion rate(%) of St. Lucia in 2005 to that in 2008?
Provide a short and direct response. 0.91. What is the difference between the highest and the second highest Education completion rate(%) of Europe(all income levels)?
Your response must be concise. 0.3. What is the difference between the highest and the second highest Education completion rate(%) in Middle income?
Keep it short and to the point. 4.21. What is the difference between the highest and the second highest Education completion rate(%) of Bahrain?
Provide a short and direct response. 0.14. What is the difference between the highest and the second highest Education completion rate(%) in St. Lucia?
Provide a short and direct response. 0.2. What is the difference between the highest and the lowest Education completion rate(%) in Europe(all income levels)?
Your answer should be very brief. 6.71. What is the difference between the highest and the lowest Education completion rate(%) of Middle income?
Provide a short and direct response. 13.33. What is the difference between the highest and the lowest Education completion rate(%) of Bahrain?
Make the answer very short. 8.28. What is the difference between the highest and the lowest Education completion rate(%) of St. Lucia?
Offer a terse response. 21.03. 